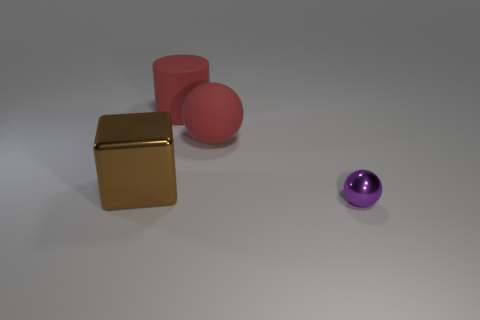Add 4 large cyan shiny spheres. How many objects exist? 8 Subtract all cylinders. How many objects are left? 3 Subtract all brown cubes. Subtract all red matte spheres. How many objects are left? 2 Add 3 small purple shiny balls. How many small purple shiny balls are left? 4 Add 1 brown rubber cylinders. How many brown rubber cylinders exist? 1 Subtract 0 purple cylinders. How many objects are left? 4 